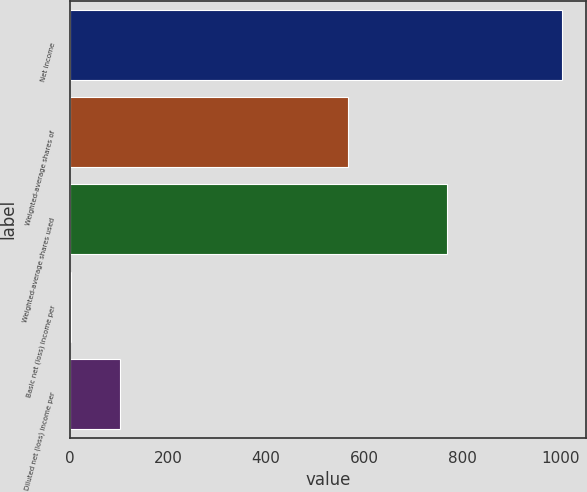<chart> <loc_0><loc_0><loc_500><loc_500><bar_chart><fcel>Net income<fcel>Weighted-average shares of<fcel>Weighted-average shares used<fcel>Basic net (loss) income per<fcel>Diluted net (loss) income per<nl><fcel>1001.4<fcel>567.5<fcel>767.42<fcel>1.76<fcel>101.72<nl></chart> 